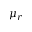Convert formula to latex. <formula><loc_0><loc_0><loc_500><loc_500>\mu _ { r }</formula> 